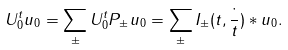Convert formula to latex. <formula><loc_0><loc_0><loc_500><loc_500>U _ { 0 } ^ { t } u _ { 0 } = \sum _ { \pm } U _ { 0 } ^ { t } P _ { \pm } u _ { 0 } = \sum _ { \pm } I _ { \pm } ( t , \frac { \cdot } { t } ) * u _ { 0 } .</formula> 